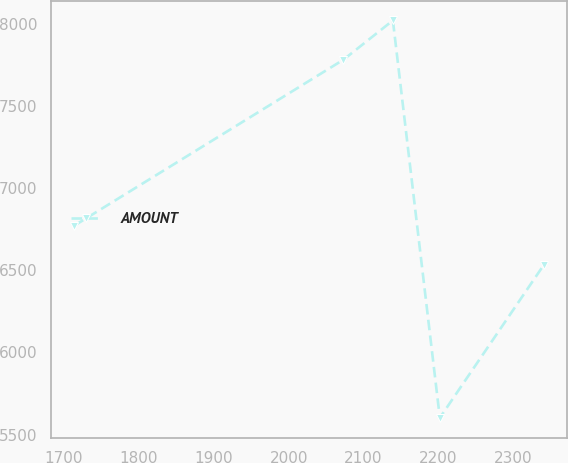Convert chart to OTSL. <chart><loc_0><loc_0><loc_500><loc_500><line_chart><ecel><fcel>AMOUNT<nl><fcel>1713.8<fcel>6771.28<nl><fcel>2073.18<fcel>7781.19<nl><fcel>2139.14<fcel>8020.08<nl><fcel>2201.81<fcel>5602.53<nl><fcel>2340.51<fcel>6532.39<nl></chart> 